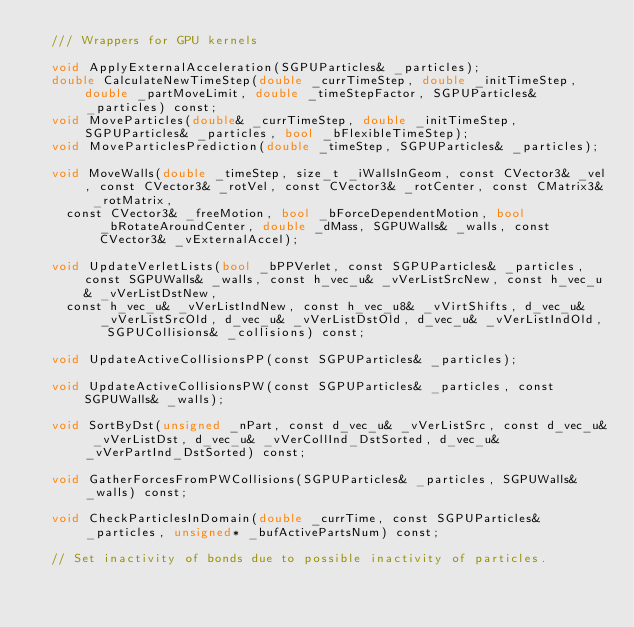Convert code to text. <code><loc_0><loc_0><loc_500><loc_500><_Cuda_>	/// Wrappers for GPU kernels

	void ApplyExternalAcceleration(SGPUParticles& _particles);
	double CalculateNewTimeStep(double _currTimeStep, double _initTimeStep, double _partMoveLimit, double _timeStepFactor, SGPUParticles& _particles) const;
	void MoveParticles(double& _currTimeStep, double _initTimeStep, SGPUParticles& _particles, bool _bFlexibleTimeStep);
	void MoveParticlesPrediction(double _timeStep, SGPUParticles& _particles);

	void MoveWalls(double _timeStep, size_t _iWallsInGeom, const CVector3& _vel, const CVector3& _rotVel, const CVector3& _rotCenter, const CMatrix3& _rotMatrix,
		const CVector3& _freeMotion, bool _bForceDependentMotion, bool _bRotateAroundCenter, double _dMass, SGPUWalls& _walls, const CVector3& _vExternalAccel);

	void UpdateVerletLists(bool _bPPVerlet, const SGPUParticles& _particles, const SGPUWalls& _walls, const h_vec_u& _vVerListSrcNew, const h_vec_u& _vVerListDstNew,
		const h_vec_u& _vVerListIndNew, const h_vec_u8& _vVirtShifts, d_vec_u& _vVerListSrcOld, d_vec_u& _vVerListDstOld, d_vec_u& _vVerListIndOld, SGPUCollisions& _collisions) const;

	void UpdateActiveCollisionsPP(const SGPUParticles& _particles);

	void UpdateActiveCollisionsPW(const SGPUParticles& _particles, const SGPUWalls& _walls);

	void SortByDst(unsigned _nPart, const d_vec_u& _vVerListSrc, const d_vec_u& _vVerListDst, d_vec_u& _vVerCollInd_DstSorted, d_vec_u& _vVerPartInd_DstSorted) const;

	void GatherForcesFromPWCollisions(SGPUParticles& _particles, SGPUWalls& _walls) const;

	void CheckParticlesInDomain(double _currTime, const SGPUParticles& _particles, unsigned* _bufActivePartsNum) const;

	// Set inactivity of bonds due to possible inactivity of particles.</code> 